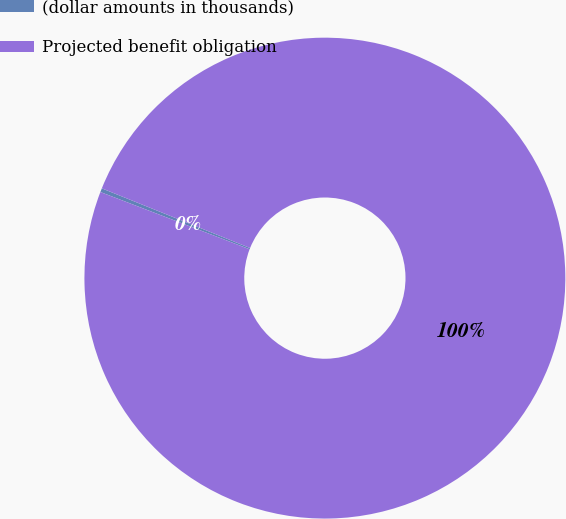Convert chart to OTSL. <chart><loc_0><loc_0><loc_500><loc_500><pie_chart><fcel>(dollar amounts in thousands)<fcel>Projected benefit obligation<nl><fcel>0.26%<fcel>99.74%<nl></chart> 